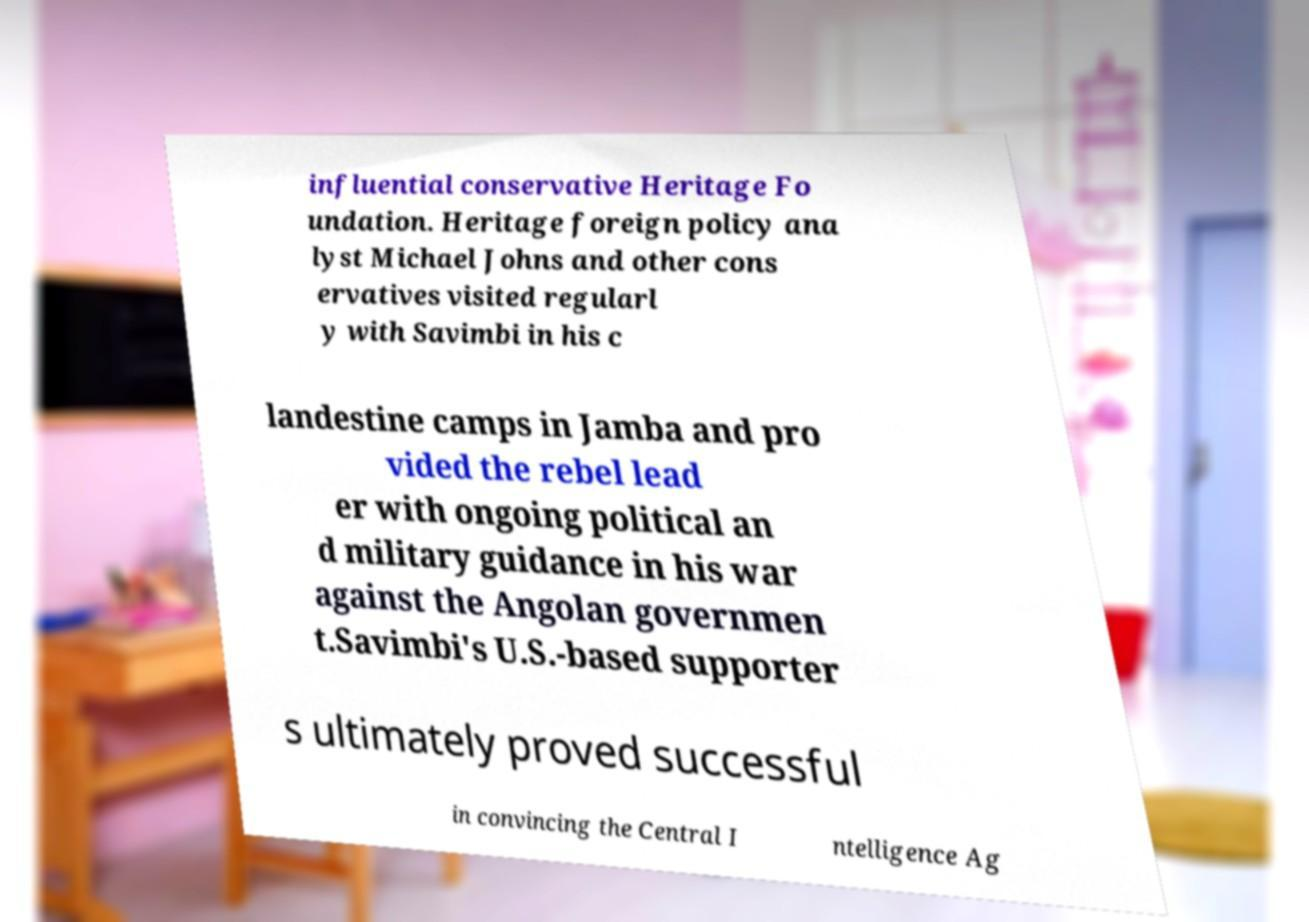For documentation purposes, I need the text within this image transcribed. Could you provide that? influential conservative Heritage Fo undation. Heritage foreign policy ana lyst Michael Johns and other cons ervatives visited regularl y with Savimbi in his c landestine camps in Jamba and pro vided the rebel lead er with ongoing political an d military guidance in his war against the Angolan governmen t.Savimbi's U.S.-based supporter s ultimately proved successful in convincing the Central I ntelligence Ag 